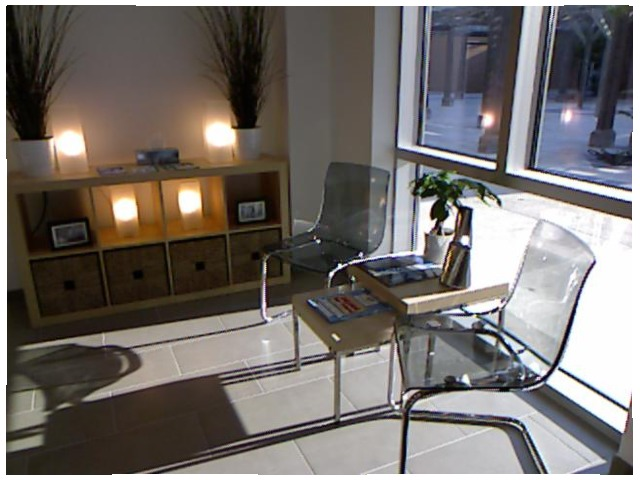<image>
Can you confirm if the tree is on the floor? No. The tree is not positioned on the floor. They may be near each other, but the tree is not supported by or resting on top of the floor. Is there a ground behind the chair? Yes. From this viewpoint, the ground is positioned behind the chair, with the chair partially or fully occluding the ground. Is the chair to the right of the chair? Yes. From this viewpoint, the chair is positioned to the right side relative to the chair. 